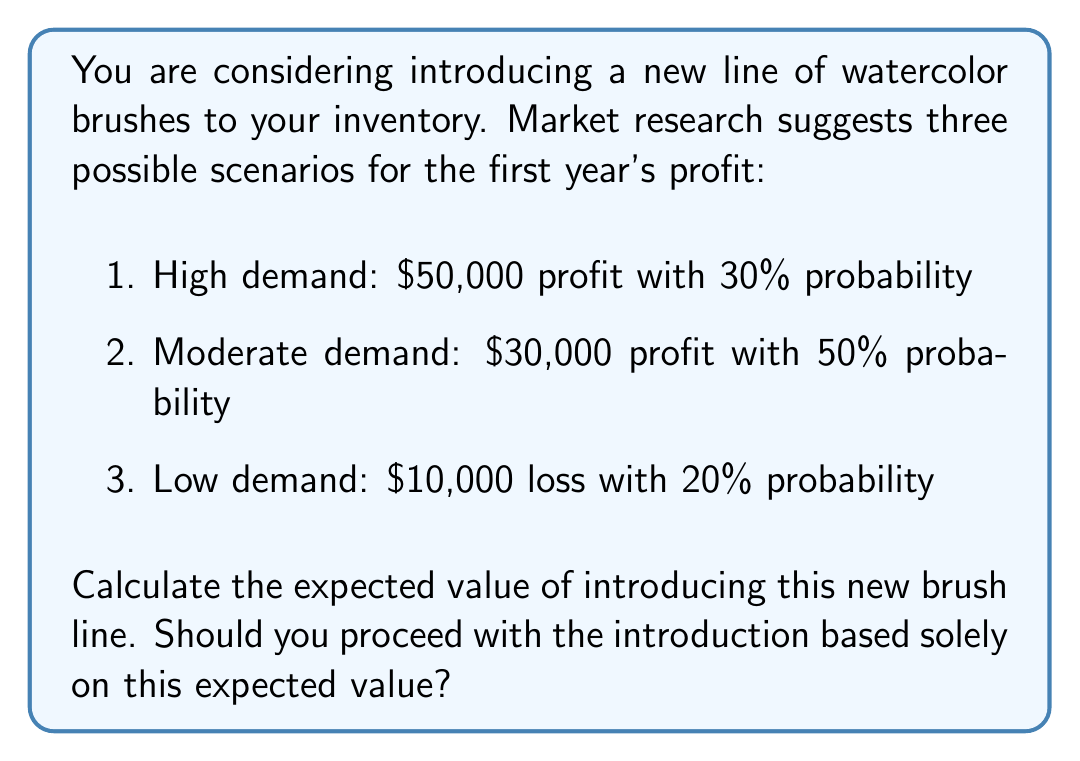Show me your answer to this math problem. To solve this problem, we need to calculate the expected value of introducing the new brush line using the given probabilities and potential profits/losses.

The expected value is calculated by multiplying each possible outcome by its probability and then summing these products.

Let's break it down step by step:

1. High demand scenario:
   Profit: $50,000
   Probability: 30% = 0.30
   Expected value: $50,000 × 0.30 = $15,000

2. Moderate demand scenario:
   Profit: $30,000
   Probability: 50% = 0.50
   Expected value: $30,000 × 0.50 = $15,000

3. Low demand scenario:
   Loss: $10,000 (negative profit)
   Probability: 20% = 0.20
   Expected value: (-$10,000) × 0.20 = -$2,000

Now, we sum these expected values:

$$ \text{Total Expected Value} = $15,000 + $15,000 + (-$2,000) = $28,000 $$

The expected value of introducing the new brush line is $28,000.

To determine whether to proceed based solely on this expected value, we should consider that it's positive, which suggests that on average, introducing the new brush line would be profitable. However, it's important to note that this decision shouldn't be based solely on expected value. Other factors such as risk tolerance, initial investment required, and long-term strategic goals should also be considered.
Answer: The expected value of introducing the new brush line is $28,000. Based solely on this positive expected value, it would be reasonable to proceed with the introduction. However, a comprehensive decision should consider additional factors beyond just the expected value. 